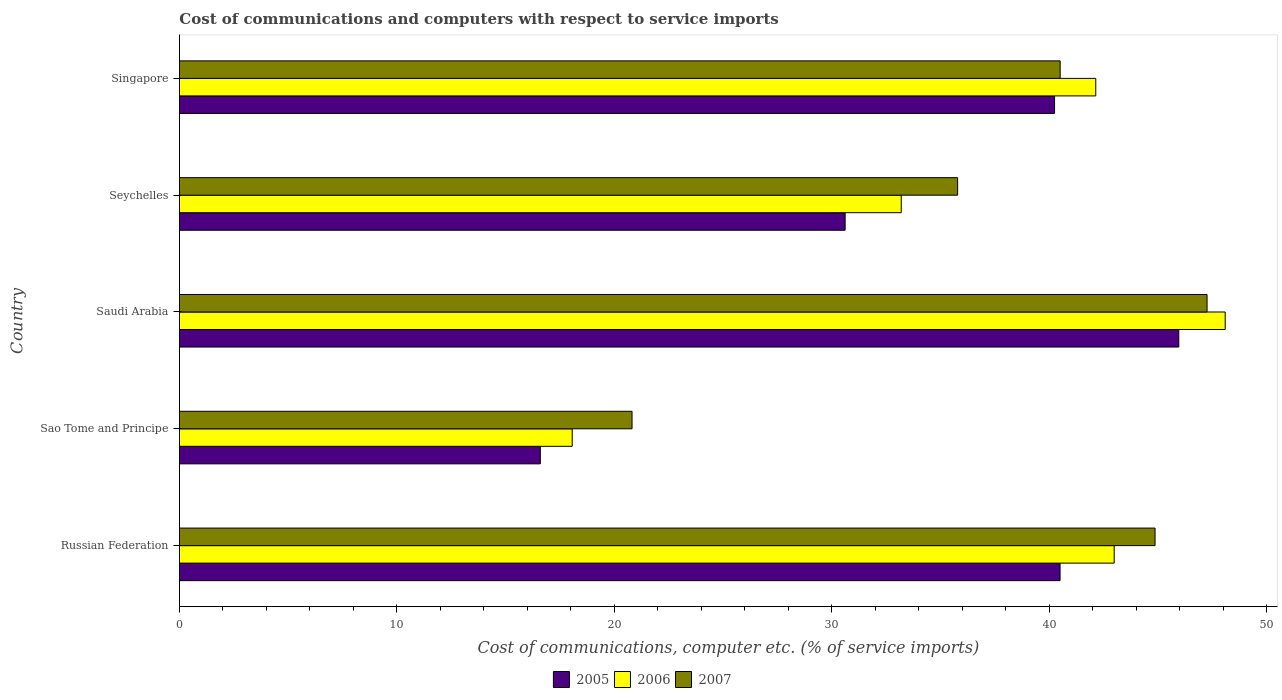Are the number of bars per tick equal to the number of legend labels?
Keep it short and to the point. Yes. Are the number of bars on each tick of the Y-axis equal?
Your answer should be compact. Yes. How many bars are there on the 1st tick from the top?
Your answer should be very brief. 3. How many bars are there on the 1st tick from the bottom?
Ensure brevity in your answer.  3. What is the label of the 2nd group of bars from the top?
Your answer should be very brief. Seychelles. What is the cost of communications and computers in 2007 in Russian Federation?
Make the answer very short. 44.86. Across all countries, what is the maximum cost of communications and computers in 2006?
Give a very brief answer. 48.08. Across all countries, what is the minimum cost of communications and computers in 2005?
Your response must be concise. 16.59. In which country was the cost of communications and computers in 2005 maximum?
Your response must be concise. Saudi Arabia. In which country was the cost of communications and computers in 2007 minimum?
Give a very brief answer. Sao Tome and Principe. What is the total cost of communications and computers in 2006 in the graph?
Offer a very short reply. 184.44. What is the difference between the cost of communications and computers in 2005 in Russian Federation and that in Singapore?
Offer a very short reply. 0.25. What is the difference between the cost of communications and computers in 2005 in Singapore and the cost of communications and computers in 2006 in Sao Tome and Principe?
Make the answer very short. 22.18. What is the average cost of communications and computers in 2006 per country?
Your answer should be compact. 36.89. What is the difference between the cost of communications and computers in 2007 and cost of communications and computers in 2005 in Russian Federation?
Your answer should be very brief. 4.37. What is the ratio of the cost of communications and computers in 2007 in Russian Federation to that in Sao Tome and Principe?
Provide a succinct answer. 2.16. Is the cost of communications and computers in 2005 in Russian Federation less than that in Saudi Arabia?
Offer a terse response. Yes. What is the difference between the highest and the second highest cost of communications and computers in 2007?
Your answer should be very brief. 2.39. What is the difference between the highest and the lowest cost of communications and computers in 2006?
Provide a short and direct response. 30.02. In how many countries, is the cost of communications and computers in 2007 greater than the average cost of communications and computers in 2007 taken over all countries?
Ensure brevity in your answer.  3. How many bars are there?
Offer a terse response. 15. How many countries are there in the graph?
Offer a terse response. 5. What is the difference between two consecutive major ticks on the X-axis?
Offer a very short reply. 10. Are the values on the major ticks of X-axis written in scientific E-notation?
Ensure brevity in your answer.  No. Does the graph contain any zero values?
Offer a very short reply. No. Where does the legend appear in the graph?
Make the answer very short. Bottom center. How many legend labels are there?
Provide a short and direct response. 3. What is the title of the graph?
Ensure brevity in your answer.  Cost of communications and computers with respect to service imports. Does "2015" appear as one of the legend labels in the graph?
Offer a very short reply. No. What is the label or title of the X-axis?
Your answer should be very brief. Cost of communications, computer etc. (% of service imports). What is the Cost of communications, computer etc. (% of service imports) of 2005 in Russian Federation?
Provide a short and direct response. 40.49. What is the Cost of communications, computer etc. (% of service imports) in 2006 in Russian Federation?
Your response must be concise. 42.98. What is the Cost of communications, computer etc. (% of service imports) in 2007 in Russian Federation?
Offer a terse response. 44.86. What is the Cost of communications, computer etc. (% of service imports) in 2005 in Sao Tome and Principe?
Provide a short and direct response. 16.59. What is the Cost of communications, computer etc. (% of service imports) of 2006 in Sao Tome and Principe?
Your response must be concise. 18.06. What is the Cost of communications, computer etc. (% of service imports) of 2007 in Sao Tome and Principe?
Make the answer very short. 20.81. What is the Cost of communications, computer etc. (% of service imports) of 2005 in Saudi Arabia?
Offer a very short reply. 45.95. What is the Cost of communications, computer etc. (% of service imports) of 2006 in Saudi Arabia?
Provide a short and direct response. 48.08. What is the Cost of communications, computer etc. (% of service imports) of 2007 in Saudi Arabia?
Provide a succinct answer. 47.25. What is the Cost of communications, computer etc. (% of service imports) in 2005 in Seychelles?
Your answer should be very brief. 30.61. What is the Cost of communications, computer etc. (% of service imports) in 2006 in Seychelles?
Your answer should be compact. 33.19. What is the Cost of communications, computer etc. (% of service imports) in 2007 in Seychelles?
Keep it short and to the point. 35.78. What is the Cost of communications, computer etc. (% of service imports) of 2005 in Singapore?
Your answer should be very brief. 40.24. What is the Cost of communications, computer etc. (% of service imports) in 2006 in Singapore?
Give a very brief answer. 42.13. What is the Cost of communications, computer etc. (% of service imports) in 2007 in Singapore?
Your response must be concise. 40.49. Across all countries, what is the maximum Cost of communications, computer etc. (% of service imports) in 2005?
Your answer should be compact. 45.95. Across all countries, what is the maximum Cost of communications, computer etc. (% of service imports) in 2006?
Your answer should be compact. 48.08. Across all countries, what is the maximum Cost of communications, computer etc. (% of service imports) in 2007?
Ensure brevity in your answer.  47.25. Across all countries, what is the minimum Cost of communications, computer etc. (% of service imports) of 2005?
Ensure brevity in your answer.  16.59. Across all countries, what is the minimum Cost of communications, computer etc. (% of service imports) of 2006?
Provide a succinct answer. 18.06. Across all countries, what is the minimum Cost of communications, computer etc. (% of service imports) of 2007?
Provide a short and direct response. 20.81. What is the total Cost of communications, computer etc. (% of service imports) of 2005 in the graph?
Offer a terse response. 173.88. What is the total Cost of communications, computer etc. (% of service imports) of 2006 in the graph?
Offer a very short reply. 184.44. What is the total Cost of communications, computer etc. (% of service imports) in 2007 in the graph?
Provide a succinct answer. 189.19. What is the difference between the Cost of communications, computer etc. (% of service imports) in 2005 in Russian Federation and that in Sao Tome and Principe?
Make the answer very short. 23.9. What is the difference between the Cost of communications, computer etc. (% of service imports) in 2006 in Russian Federation and that in Sao Tome and Principe?
Ensure brevity in your answer.  24.92. What is the difference between the Cost of communications, computer etc. (% of service imports) in 2007 in Russian Federation and that in Sao Tome and Principe?
Your answer should be very brief. 24.05. What is the difference between the Cost of communications, computer etc. (% of service imports) of 2005 in Russian Federation and that in Saudi Arabia?
Your answer should be very brief. -5.46. What is the difference between the Cost of communications, computer etc. (% of service imports) in 2006 in Russian Federation and that in Saudi Arabia?
Your response must be concise. -5.1. What is the difference between the Cost of communications, computer etc. (% of service imports) in 2007 in Russian Federation and that in Saudi Arabia?
Ensure brevity in your answer.  -2.39. What is the difference between the Cost of communications, computer etc. (% of service imports) in 2005 in Russian Federation and that in Seychelles?
Ensure brevity in your answer.  9.88. What is the difference between the Cost of communications, computer etc. (% of service imports) in 2006 in Russian Federation and that in Seychelles?
Your answer should be very brief. 9.79. What is the difference between the Cost of communications, computer etc. (% of service imports) in 2007 in Russian Federation and that in Seychelles?
Give a very brief answer. 9.08. What is the difference between the Cost of communications, computer etc. (% of service imports) in 2005 in Russian Federation and that in Singapore?
Offer a very short reply. 0.25. What is the difference between the Cost of communications, computer etc. (% of service imports) of 2006 in Russian Federation and that in Singapore?
Your answer should be very brief. 0.85. What is the difference between the Cost of communications, computer etc. (% of service imports) in 2007 in Russian Federation and that in Singapore?
Provide a succinct answer. 4.36. What is the difference between the Cost of communications, computer etc. (% of service imports) in 2005 in Sao Tome and Principe and that in Saudi Arabia?
Provide a succinct answer. -29.35. What is the difference between the Cost of communications, computer etc. (% of service imports) of 2006 in Sao Tome and Principe and that in Saudi Arabia?
Provide a succinct answer. -30.02. What is the difference between the Cost of communications, computer etc. (% of service imports) of 2007 in Sao Tome and Principe and that in Saudi Arabia?
Make the answer very short. -26.44. What is the difference between the Cost of communications, computer etc. (% of service imports) of 2005 in Sao Tome and Principe and that in Seychelles?
Your answer should be compact. -14.01. What is the difference between the Cost of communications, computer etc. (% of service imports) in 2006 in Sao Tome and Principe and that in Seychelles?
Ensure brevity in your answer.  -15.13. What is the difference between the Cost of communications, computer etc. (% of service imports) of 2007 in Sao Tome and Principe and that in Seychelles?
Ensure brevity in your answer.  -14.97. What is the difference between the Cost of communications, computer etc. (% of service imports) of 2005 in Sao Tome and Principe and that in Singapore?
Your answer should be compact. -23.64. What is the difference between the Cost of communications, computer etc. (% of service imports) in 2006 in Sao Tome and Principe and that in Singapore?
Ensure brevity in your answer.  -24.07. What is the difference between the Cost of communications, computer etc. (% of service imports) in 2007 in Sao Tome and Principe and that in Singapore?
Your answer should be very brief. -19.68. What is the difference between the Cost of communications, computer etc. (% of service imports) in 2005 in Saudi Arabia and that in Seychelles?
Offer a terse response. 15.34. What is the difference between the Cost of communications, computer etc. (% of service imports) in 2006 in Saudi Arabia and that in Seychelles?
Offer a terse response. 14.9. What is the difference between the Cost of communications, computer etc. (% of service imports) in 2007 in Saudi Arabia and that in Seychelles?
Your answer should be very brief. 11.47. What is the difference between the Cost of communications, computer etc. (% of service imports) of 2005 in Saudi Arabia and that in Singapore?
Ensure brevity in your answer.  5.71. What is the difference between the Cost of communications, computer etc. (% of service imports) in 2006 in Saudi Arabia and that in Singapore?
Offer a terse response. 5.95. What is the difference between the Cost of communications, computer etc. (% of service imports) of 2007 in Saudi Arabia and that in Singapore?
Give a very brief answer. 6.75. What is the difference between the Cost of communications, computer etc. (% of service imports) in 2005 in Seychelles and that in Singapore?
Offer a terse response. -9.63. What is the difference between the Cost of communications, computer etc. (% of service imports) of 2006 in Seychelles and that in Singapore?
Provide a short and direct response. -8.94. What is the difference between the Cost of communications, computer etc. (% of service imports) of 2007 in Seychelles and that in Singapore?
Give a very brief answer. -4.71. What is the difference between the Cost of communications, computer etc. (% of service imports) in 2005 in Russian Federation and the Cost of communications, computer etc. (% of service imports) in 2006 in Sao Tome and Principe?
Your answer should be very brief. 22.43. What is the difference between the Cost of communications, computer etc. (% of service imports) of 2005 in Russian Federation and the Cost of communications, computer etc. (% of service imports) of 2007 in Sao Tome and Principe?
Give a very brief answer. 19.68. What is the difference between the Cost of communications, computer etc. (% of service imports) in 2006 in Russian Federation and the Cost of communications, computer etc. (% of service imports) in 2007 in Sao Tome and Principe?
Give a very brief answer. 22.17. What is the difference between the Cost of communications, computer etc. (% of service imports) of 2005 in Russian Federation and the Cost of communications, computer etc. (% of service imports) of 2006 in Saudi Arabia?
Make the answer very short. -7.59. What is the difference between the Cost of communications, computer etc. (% of service imports) of 2005 in Russian Federation and the Cost of communications, computer etc. (% of service imports) of 2007 in Saudi Arabia?
Your answer should be compact. -6.76. What is the difference between the Cost of communications, computer etc. (% of service imports) in 2006 in Russian Federation and the Cost of communications, computer etc. (% of service imports) in 2007 in Saudi Arabia?
Offer a terse response. -4.27. What is the difference between the Cost of communications, computer etc. (% of service imports) in 2005 in Russian Federation and the Cost of communications, computer etc. (% of service imports) in 2006 in Seychelles?
Make the answer very short. 7.3. What is the difference between the Cost of communications, computer etc. (% of service imports) in 2005 in Russian Federation and the Cost of communications, computer etc. (% of service imports) in 2007 in Seychelles?
Give a very brief answer. 4.71. What is the difference between the Cost of communications, computer etc. (% of service imports) in 2006 in Russian Federation and the Cost of communications, computer etc. (% of service imports) in 2007 in Seychelles?
Provide a succinct answer. 7.2. What is the difference between the Cost of communications, computer etc. (% of service imports) of 2005 in Russian Federation and the Cost of communications, computer etc. (% of service imports) of 2006 in Singapore?
Ensure brevity in your answer.  -1.64. What is the difference between the Cost of communications, computer etc. (% of service imports) of 2005 in Russian Federation and the Cost of communications, computer etc. (% of service imports) of 2007 in Singapore?
Keep it short and to the point. -0. What is the difference between the Cost of communications, computer etc. (% of service imports) of 2006 in Russian Federation and the Cost of communications, computer etc. (% of service imports) of 2007 in Singapore?
Provide a succinct answer. 2.48. What is the difference between the Cost of communications, computer etc. (% of service imports) in 2005 in Sao Tome and Principe and the Cost of communications, computer etc. (% of service imports) in 2006 in Saudi Arabia?
Make the answer very short. -31.49. What is the difference between the Cost of communications, computer etc. (% of service imports) in 2005 in Sao Tome and Principe and the Cost of communications, computer etc. (% of service imports) in 2007 in Saudi Arabia?
Keep it short and to the point. -30.65. What is the difference between the Cost of communications, computer etc. (% of service imports) in 2006 in Sao Tome and Principe and the Cost of communications, computer etc. (% of service imports) in 2007 in Saudi Arabia?
Give a very brief answer. -29.19. What is the difference between the Cost of communications, computer etc. (% of service imports) in 2005 in Sao Tome and Principe and the Cost of communications, computer etc. (% of service imports) in 2006 in Seychelles?
Offer a terse response. -16.59. What is the difference between the Cost of communications, computer etc. (% of service imports) in 2005 in Sao Tome and Principe and the Cost of communications, computer etc. (% of service imports) in 2007 in Seychelles?
Offer a terse response. -19.19. What is the difference between the Cost of communications, computer etc. (% of service imports) of 2006 in Sao Tome and Principe and the Cost of communications, computer etc. (% of service imports) of 2007 in Seychelles?
Make the answer very short. -17.72. What is the difference between the Cost of communications, computer etc. (% of service imports) in 2005 in Sao Tome and Principe and the Cost of communications, computer etc. (% of service imports) in 2006 in Singapore?
Give a very brief answer. -25.54. What is the difference between the Cost of communications, computer etc. (% of service imports) in 2005 in Sao Tome and Principe and the Cost of communications, computer etc. (% of service imports) in 2007 in Singapore?
Your response must be concise. -23.9. What is the difference between the Cost of communications, computer etc. (% of service imports) of 2006 in Sao Tome and Principe and the Cost of communications, computer etc. (% of service imports) of 2007 in Singapore?
Provide a short and direct response. -22.44. What is the difference between the Cost of communications, computer etc. (% of service imports) of 2005 in Saudi Arabia and the Cost of communications, computer etc. (% of service imports) of 2006 in Seychelles?
Your response must be concise. 12.76. What is the difference between the Cost of communications, computer etc. (% of service imports) of 2005 in Saudi Arabia and the Cost of communications, computer etc. (% of service imports) of 2007 in Seychelles?
Your answer should be compact. 10.17. What is the difference between the Cost of communications, computer etc. (% of service imports) of 2006 in Saudi Arabia and the Cost of communications, computer etc. (% of service imports) of 2007 in Seychelles?
Provide a succinct answer. 12.3. What is the difference between the Cost of communications, computer etc. (% of service imports) of 2005 in Saudi Arabia and the Cost of communications, computer etc. (% of service imports) of 2006 in Singapore?
Offer a very short reply. 3.82. What is the difference between the Cost of communications, computer etc. (% of service imports) in 2005 in Saudi Arabia and the Cost of communications, computer etc. (% of service imports) in 2007 in Singapore?
Keep it short and to the point. 5.45. What is the difference between the Cost of communications, computer etc. (% of service imports) of 2006 in Saudi Arabia and the Cost of communications, computer etc. (% of service imports) of 2007 in Singapore?
Your response must be concise. 7.59. What is the difference between the Cost of communications, computer etc. (% of service imports) in 2005 in Seychelles and the Cost of communications, computer etc. (% of service imports) in 2006 in Singapore?
Provide a short and direct response. -11.52. What is the difference between the Cost of communications, computer etc. (% of service imports) of 2005 in Seychelles and the Cost of communications, computer etc. (% of service imports) of 2007 in Singapore?
Make the answer very short. -9.89. What is the difference between the Cost of communications, computer etc. (% of service imports) of 2006 in Seychelles and the Cost of communications, computer etc. (% of service imports) of 2007 in Singapore?
Keep it short and to the point. -7.31. What is the average Cost of communications, computer etc. (% of service imports) in 2005 per country?
Your answer should be very brief. 34.78. What is the average Cost of communications, computer etc. (% of service imports) in 2006 per country?
Your answer should be very brief. 36.89. What is the average Cost of communications, computer etc. (% of service imports) in 2007 per country?
Your response must be concise. 37.84. What is the difference between the Cost of communications, computer etc. (% of service imports) of 2005 and Cost of communications, computer etc. (% of service imports) of 2006 in Russian Federation?
Your answer should be compact. -2.49. What is the difference between the Cost of communications, computer etc. (% of service imports) in 2005 and Cost of communications, computer etc. (% of service imports) in 2007 in Russian Federation?
Offer a very short reply. -4.37. What is the difference between the Cost of communications, computer etc. (% of service imports) in 2006 and Cost of communications, computer etc. (% of service imports) in 2007 in Russian Federation?
Keep it short and to the point. -1.88. What is the difference between the Cost of communications, computer etc. (% of service imports) of 2005 and Cost of communications, computer etc. (% of service imports) of 2006 in Sao Tome and Principe?
Give a very brief answer. -1.47. What is the difference between the Cost of communications, computer etc. (% of service imports) in 2005 and Cost of communications, computer etc. (% of service imports) in 2007 in Sao Tome and Principe?
Your answer should be compact. -4.22. What is the difference between the Cost of communications, computer etc. (% of service imports) in 2006 and Cost of communications, computer etc. (% of service imports) in 2007 in Sao Tome and Principe?
Provide a succinct answer. -2.75. What is the difference between the Cost of communications, computer etc. (% of service imports) of 2005 and Cost of communications, computer etc. (% of service imports) of 2006 in Saudi Arabia?
Keep it short and to the point. -2.13. What is the difference between the Cost of communications, computer etc. (% of service imports) of 2005 and Cost of communications, computer etc. (% of service imports) of 2007 in Saudi Arabia?
Make the answer very short. -1.3. What is the difference between the Cost of communications, computer etc. (% of service imports) in 2006 and Cost of communications, computer etc. (% of service imports) in 2007 in Saudi Arabia?
Provide a short and direct response. 0.83. What is the difference between the Cost of communications, computer etc. (% of service imports) of 2005 and Cost of communications, computer etc. (% of service imports) of 2006 in Seychelles?
Provide a succinct answer. -2.58. What is the difference between the Cost of communications, computer etc. (% of service imports) in 2005 and Cost of communications, computer etc. (% of service imports) in 2007 in Seychelles?
Keep it short and to the point. -5.17. What is the difference between the Cost of communications, computer etc. (% of service imports) of 2006 and Cost of communications, computer etc. (% of service imports) of 2007 in Seychelles?
Offer a terse response. -2.59. What is the difference between the Cost of communications, computer etc. (% of service imports) of 2005 and Cost of communications, computer etc. (% of service imports) of 2006 in Singapore?
Your answer should be very brief. -1.89. What is the difference between the Cost of communications, computer etc. (% of service imports) of 2005 and Cost of communications, computer etc. (% of service imports) of 2007 in Singapore?
Offer a terse response. -0.26. What is the difference between the Cost of communications, computer etc. (% of service imports) in 2006 and Cost of communications, computer etc. (% of service imports) in 2007 in Singapore?
Provide a succinct answer. 1.64. What is the ratio of the Cost of communications, computer etc. (% of service imports) in 2005 in Russian Federation to that in Sao Tome and Principe?
Offer a very short reply. 2.44. What is the ratio of the Cost of communications, computer etc. (% of service imports) of 2006 in Russian Federation to that in Sao Tome and Principe?
Your answer should be compact. 2.38. What is the ratio of the Cost of communications, computer etc. (% of service imports) of 2007 in Russian Federation to that in Sao Tome and Principe?
Offer a very short reply. 2.16. What is the ratio of the Cost of communications, computer etc. (% of service imports) in 2005 in Russian Federation to that in Saudi Arabia?
Your answer should be compact. 0.88. What is the ratio of the Cost of communications, computer etc. (% of service imports) in 2006 in Russian Federation to that in Saudi Arabia?
Ensure brevity in your answer.  0.89. What is the ratio of the Cost of communications, computer etc. (% of service imports) of 2007 in Russian Federation to that in Saudi Arabia?
Give a very brief answer. 0.95. What is the ratio of the Cost of communications, computer etc. (% of service imports) in 2005 in Russian Federation to that in Seychelles?
Your answer should be compact. 1.32. What is the ratio of the Cost of communications, computer etc. (% of service imports) in 2006 in Russian Federation to that in Seychelles?
Keep it short and to the point. 1.29. What is the ratio of the Cost of communications, computer etc. (% of service imports) in 2007 in Russian Federation to that in Seychelles?
Your answer should be very brief. 1.25. What is the ratio of the Cost of communications, computer etc. (% of service imports) of 2005 in Russian Federation to that in Singapore?
Your answer should be very brief. 1.01. What is the ratio of the Cost of communications, computer etc. (% of service imports) of 2006 in Russian Federation to that in Singapore?
Offer a terse response. 1.02. What is the ratio of the Cost of communications, computer etc. (% of service imports) of 2007 in Russian Federation to that in Singapore?
Your answer should be compact. 1.11. What is the ratio of the Cost of communications, computer etc. (% of service imports) of 2005 in Sao Tome and Principe to that in Saudi Arabia?
Provide a succinct answer. 0.36. What is the ratio of the Cost of communications, computer etc. (% of service imports) of 2006 in Sao Tome and Principe to that in Saudi Arabia?
Provide a short and direct response. 0.38. What is the ratio of the Cost of communications, computer etc. (% of service imports) in 2007 in Sao Tome and Principe to that in Saudi Arabia?
Ensure brevity in your answer.  0.44. What is the ratio of the Cost of communications, computer etc. (% of service imports) in 2005 in Sao Tome and Principe to that in Seychelles?
Give a very brief answer. 0.54. What is the ratio of the Cost of communications, computer etc. (% of service imports) in 2006 in Sao Tome and Principe to that in Seychelles?
Offer a very short reply. 0.54. What is the ratio of the Cost of communications, computer etc. (% of service imports) of 2007 in Sao Tome and Principe to that in Seychelles?
Offer a terse response. 0.58. What is the ratio of the Cost of communications, computer etc. (% of service imports) of 2005 in Sao Tome and Principe to that in Singapore?
Offer a terse response. 0.41. What is the ratio of the Cost of communications, computer etc. (% of service imports) of 2006 in Sao Tome and Principe to that in Singapore?
Keep it short and to the point. 0.43. What is the ratio of the Cost of communications, computer etc. (% of service imports) in 2007 in Sao Tome and Principe to that in Singapore?
Provide a succinct answer. 0.51. What is the ratio of the Cost of communications, computer etc. (% of service imports) in 2005 in Saudi Arabia to that in Seychelles?
Your response must be concise. 1.5. What is the ratio of the Cost of communications, computer etc. (% of service imports) of 2006 in Saudi Arabia to that in Seychelles?
Your answer should be compact. 1.45. What is the ratio of the Cost of communications, computer etc. (% of service imports) in 2007 in Saudi Arabia to that in Seychelles?
Ensure brevity in your answer.  1.32. What is the ratio of the Cost of communications, computer etc. (% of service imports) of 2005 in Saudi Arabia to that in Singapore?
Provide a succinct answer. 1.14. What is the ratio of the Cost of communications, computer etc. (% of service imports) in 2006 in Saudi Arabia to that in Singapore?
Provide a succinct answer. 1.14. What is the ratio of the Cost of communications, computer etc. (% of service imports) of 2007 in Saudi Arabia to that in Singapore?
Make the answer very short. 1.17. What is the ratio of the Cost of communications, computer etc. (% of service imports) in 2005 in Seychelles to that in Singapore?
Provide a succinct answer. 0.76. What is the ratio of the Cost of communications, computer etc. (% of service imports) in 2006 in Seychelles to that in Singapore?
Provide a succinct answer. 0.79. What is the ratio of the Cost of communications, computer etc. (% of service imports) of 2007 in Seychelles to that in Singapore?
Give a very brief answer. 0.88. What is the difference between the highest and the second highest Cost of communications, computer etc. (% of service imports) of 2005?
Your response must be concise. 5.46. What is the difference between the highest and the second highest Cost of communications, computer etc. (% of service imports) in 2006?
Offer a very short reply. 5.1. What is the difference between the highest and the second highest Cost of communications, computer etc. (% of service imports) in 2007?
Give a very brief answer. 2.39. What is the difference between the highest and the lowest Cost of communications, computer etc. (% of service imports) in 2005?
Your answer should be very brief. 29.35. What is the difference between the highest and the lowest Cost of communications, computer etc. (% of service imports) of 2006?
Your response must be concise. 30.02. What is the difference between the highest and the lowest Cost of communications, computer etc. (% of service imports) of 2007?
Offer a terse response. 26.44. 